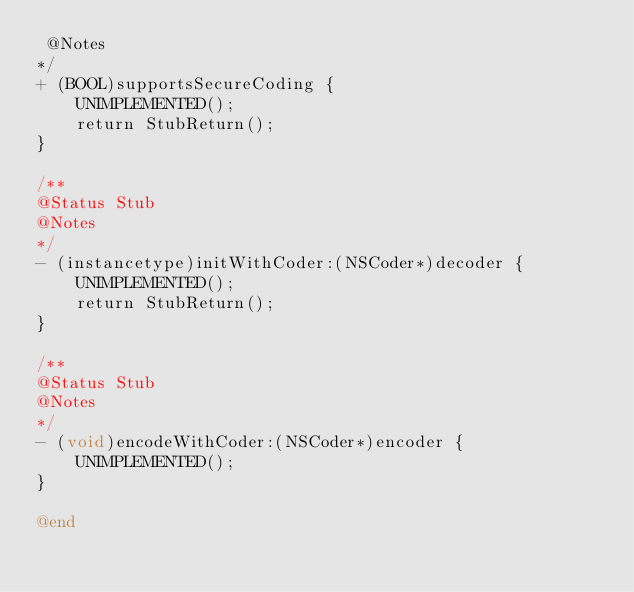<code> <loc_0><loc_0><loc_500><loc_500><_ObjectiveC_> @Notes
*/
+ (BOOL)supportsSecureCoding {
    UNIMPLEMENTED();
    return StubReturn();
}

/**
@Status Stub
@Notes
*/
- (instancetype)initWithCoder:(NSCoder*)decoder {
    UNIMPLEMENTED();
    return StubReturn();
}

/**
@Status Stub
@Notes
*/
- (void)encodeWithCoder:(NSCoder*)encoder {
    UNIMPLEMENTED();
}

@end
</code> 